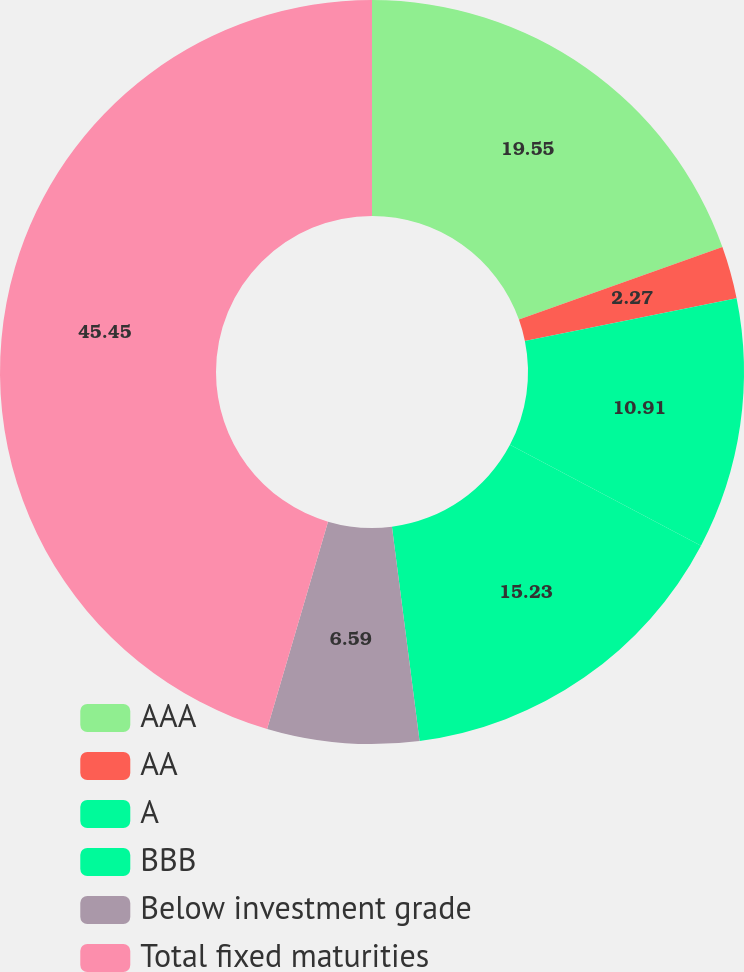Convert chart. <chart><loc_0><loc_0><loc_500><loc_500><pie_chart><fcel>AAA<fcel>AA<fcel>A<fcel>BBB<fcel>Below investment grade<fcel>Total fixed maturities<nl><fcel>19.55%<fcel>2.27%<fcel>10.91%<fcel>15.23%<fcel>6.59%<fcel>45.45%<nl></chart> 